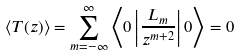Convert formula to latex. <formula><loc_0><loc_0><loc_500><loc_500>\langle T ( z ) \rangle = \sum _ { m = - \infty } ^ { \infty } \left \langle 0 \left | \frac { L _ { m } } { z ^ { m + 2 } } \right | 0 \right \rangle = 0</formula> 